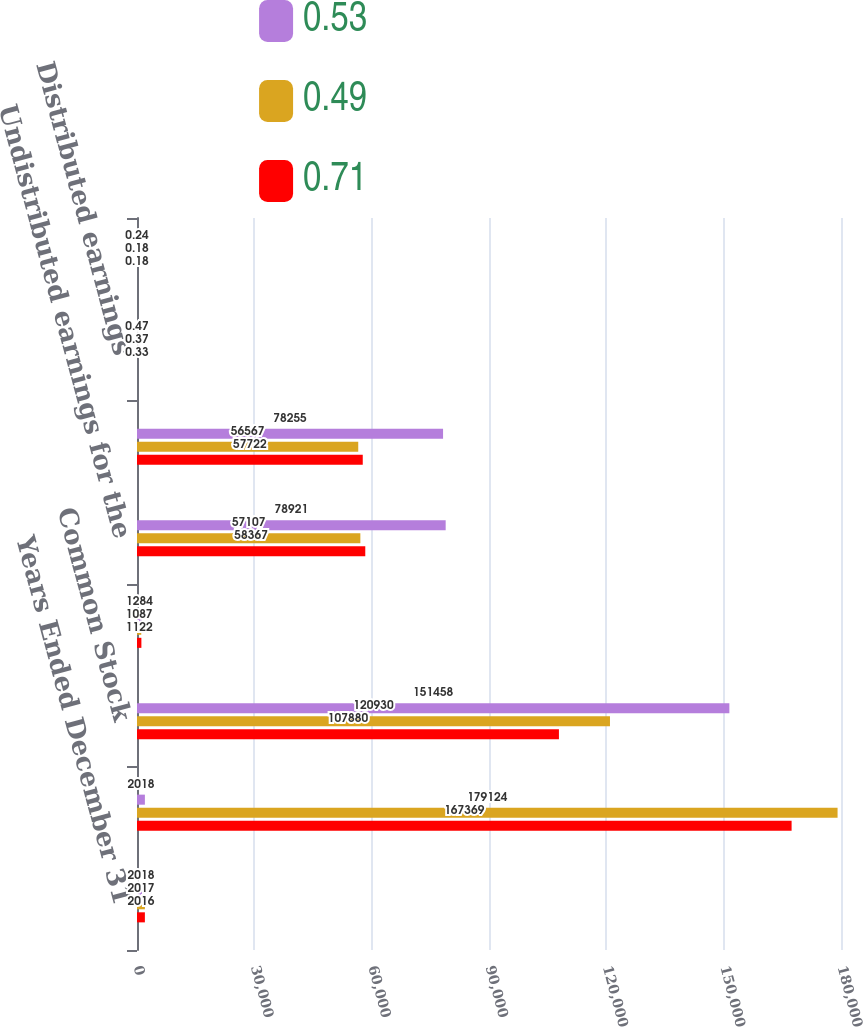<chart> <loc_0><loc_0><loc_500><loc_500><stacked_bar_chart><ecel><fcel>Years Ended December 31<fcel>Net income available to<fcel>Common Stock<fcel>Restricted shares of common<fcel>Undistributed earnings for the<fcel>Common stock<fcel>Distributed earnings<fcel>Undistributed earnings<nl><fcel>0.53<fcel>2018<fcel>2018<fcel>151458<fcel>1284<fcel>78921<fcel>78255<fcel>0.47<fcel>0.24<nl><fcel>0.49<fcel>2017<fcel>179124<fcel>120930<fcel>1087<fcel>57107<fcel>56567<fcel>0.37<fcel>0.18<nl><fcel>0.71<fcel>2016<fcel>167369<fcel>107880<fcel>1122<fcel>58367<fcel>57722<fcel>0.33<fcel>0.18<nl></chart> 